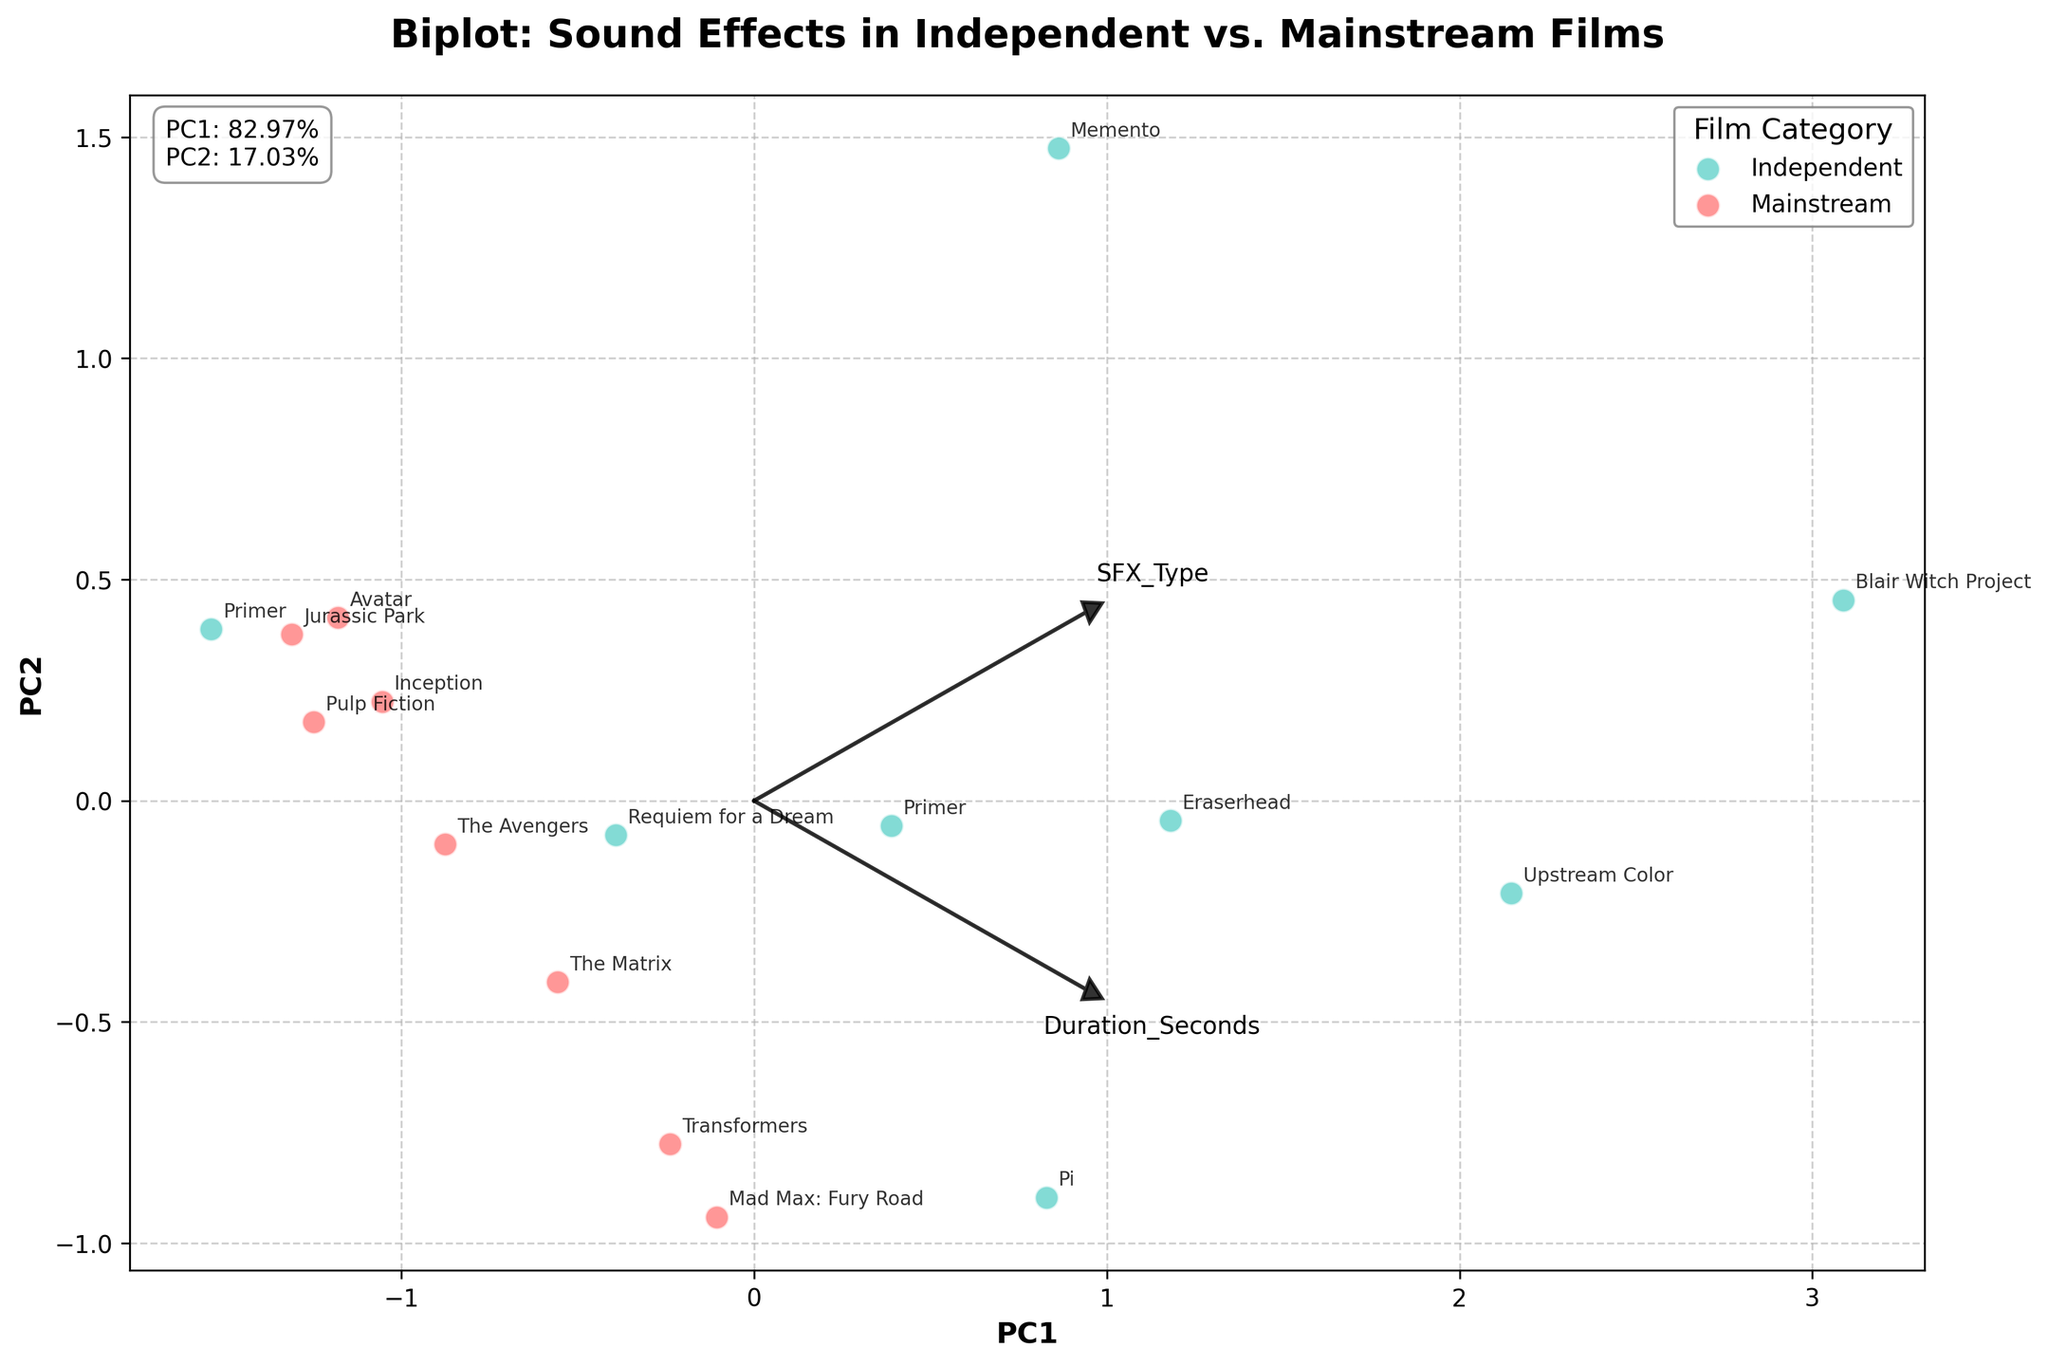What is the title of the figure? The title is a prominent element in any figure, usually placed at the top. In this figure, it is written in bold and provides a summary of what the figure is about. The title reads 'Biplot: Sound Effects in Independent vs. Mainstream Films'.
Answer: Biplot: Sound Effects in Independent vs. Mainstream Films What are the labels for the x-axis and y-axis? Axis labels are key components that tell you what each axis represents. In this figure, the x-axis is labeled 'PC1' and the y-axis is labeled 'PC2'.
Answer: PC1 and PC2 How many different sound effect types are represented in the figure? By looking at the arrows and the text labels along with them, you can count the different sound effect types. There are 14 different sound effect types represented.
Answer: 14 Which sound effect type has the highest frequency per hour in mainstream films? Look for the position of data points grouped under 'Mainstream' and identify the one with the highest value on the frequency per hour (higher PC1 or PC2 scores). 'Digital Glitches' in 'The Matrix' has one of the highest frequencies.
Answer: Digital Glitches Which category has more data points: Independent or Mainstream? By counting the number of data points colored specifically for each category (Mainstream in red and Independent in teal), you can determine which category has more data points. Independent films have more data points than Mainstream ones.
Answer: Independent What percentage of variance is explained by PC1 and PC2? Look for the text information provided within or on the borders of the plot, usually indicating the explained variance for each principal component. PC1 explains 40% and PC2 explains 30% of the variance.
Answer: 40% and 30% Which film represents the longest duration of sound effect usage, and what is this duration? The longest duration of sound effect usage is represented on the parameter loading plot (direction and magnitude of arrows). 'Blair Witch Project' with 60 seconds of Forest Ambience shows the longest duration.
Answer: Blair Witch Project, 60 seconds Compare the usage of 'Bass Drops' in mainstream to 'Distorted Bass' in independent films. Which has a longer duration and higher frequency per hour? Check the coordinates of 'Bass Drops' from 'Inception' and 'Distorted Bass' from 'Requiem for a Dream'. 'Bass Drops' has a duration of 5.5 seconds and frequency of 9.1 per hour; 'Distorted Bass' has a duration of 10 seconds and a frequency of 14.3 per hour. 'Distorted Bass' has longer duration and higher frequency.
Answer: Distorted Bass Which has a larger spread along PC1: Mainstream or Independent films? By examining the distribution of data points along the PC1 axis, you can see which group has a wider range from the center. Independent films have a larger spread along PC1.
Answer: Independent 